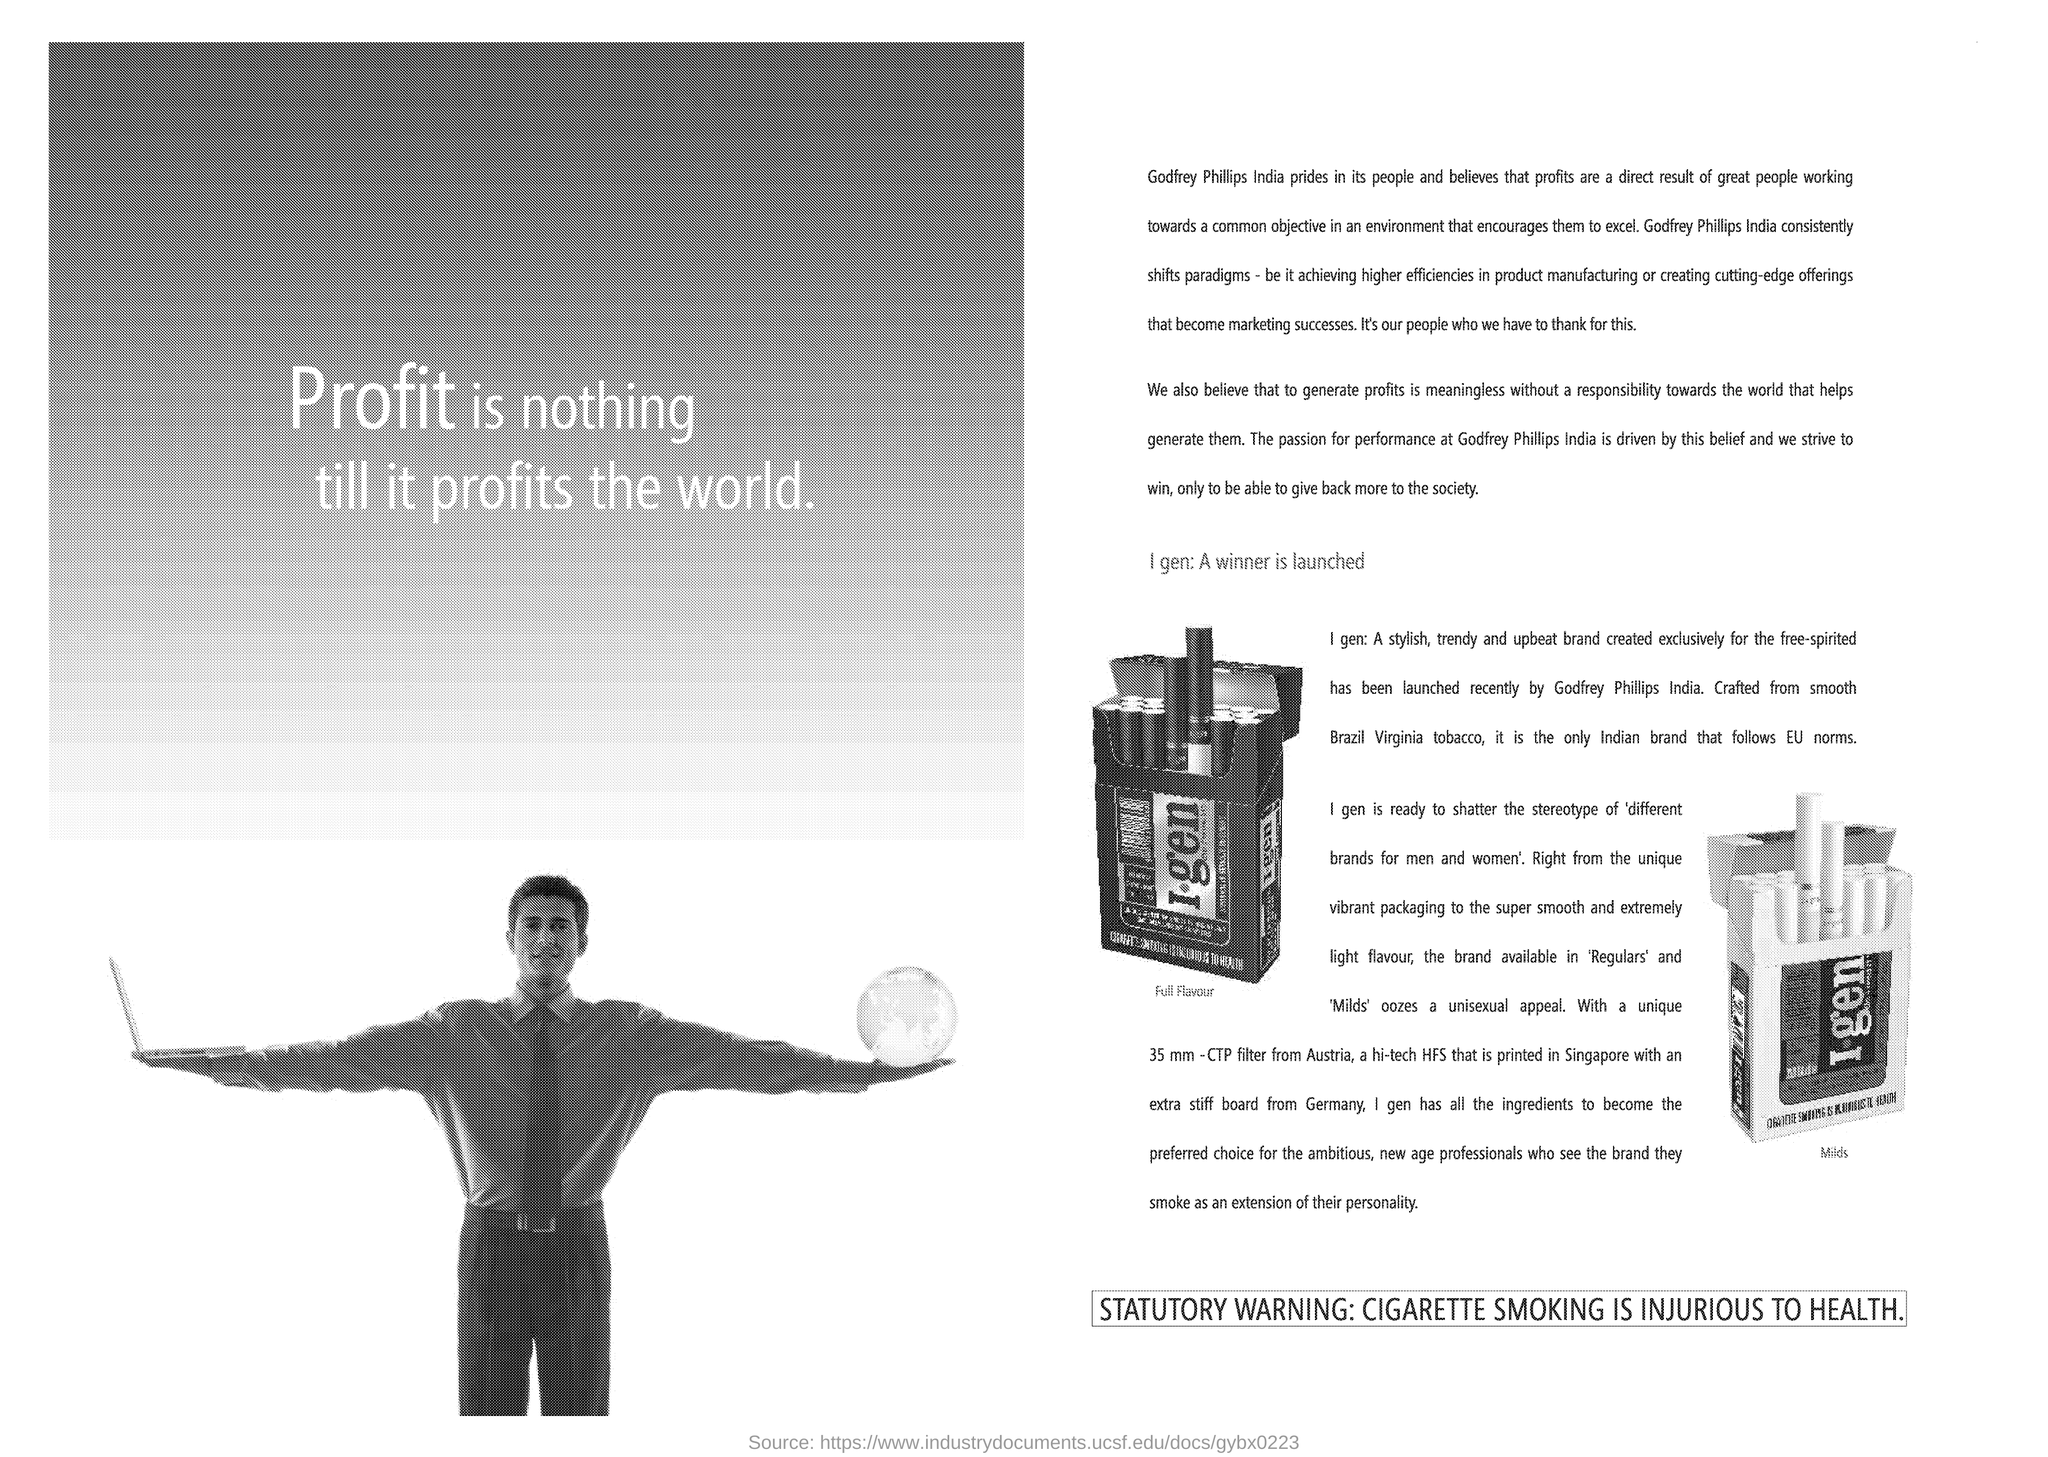What statutory warning is mentioned in document?
Keep it short and to the point. CIGARETTE SMOKING IS INJURIOUS TO HEALTH. 